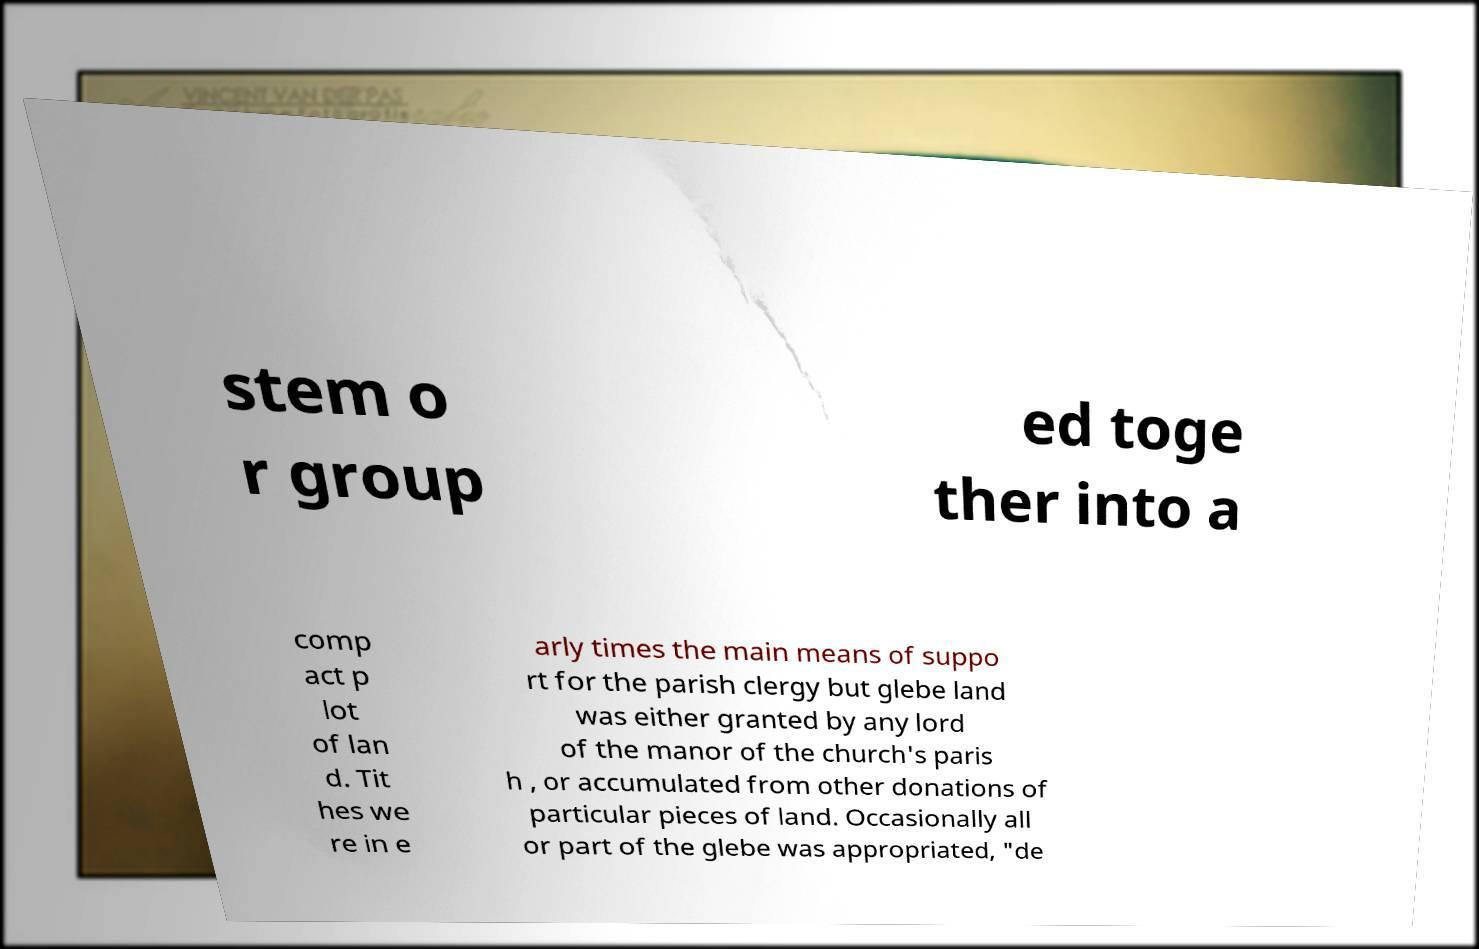For documentation purposes, I need the text within this image transcribed. Could you provide that? stem o r group ed toge ther into a comp act p lot of lan d. Tit hes we re in e arly times the main means of suppo rt for the parish clergy but glebe land was either granted by any lord of the manor of the church's paris h , or accumulated from other donations of particular pieces of land. Occasionally all or part of the glebe was appropriated, "de 